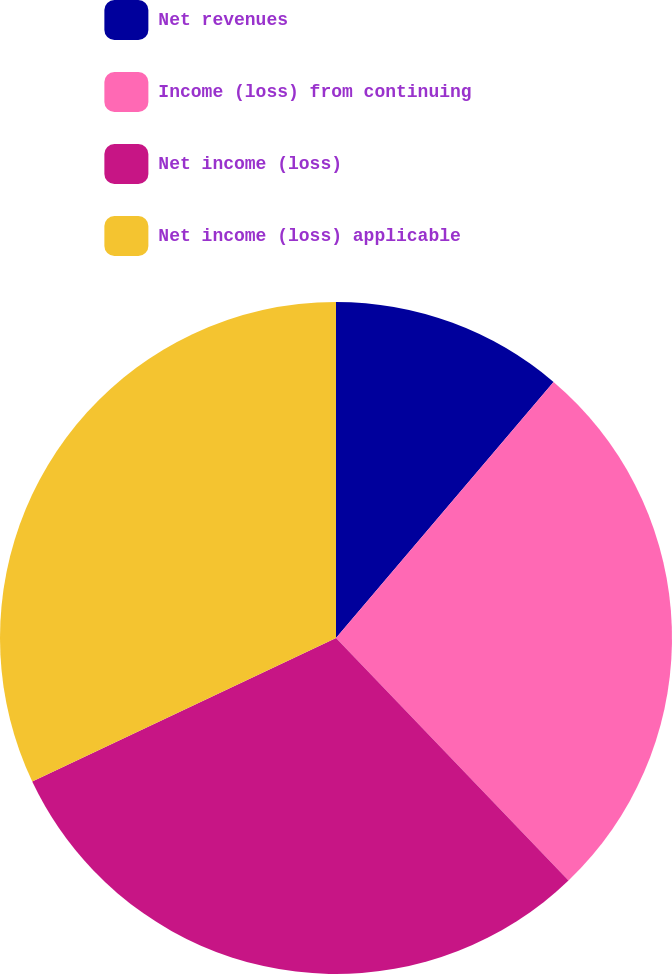Convert chart to OTSL. <chart><loc_0><loc_0><loc_500><loc_500><pie_chart><fcel>Net revenues<fcel>Income (loss) from continuing<fcel>Net income (loss)<fcel>Net income (loss) applicable<nl><fcel>11.21%<fcel>26.63%<fcel>30.14%<fcel>32.03%<nl></chart> 